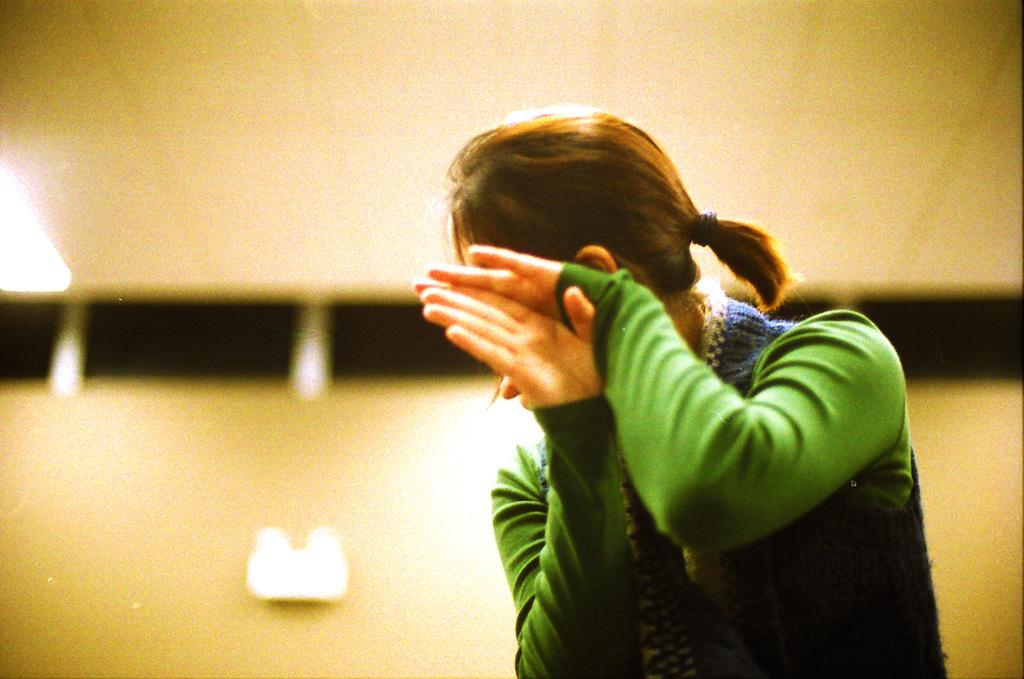Who is the main subject in the image? There is a girl in the image. What is the girl wearing? The girl is wearing a green top. What can be seen in the background of the image? There is a wall and black objects in the background of the image. Can you describe the lighting in the image? There is a light visible in the image. What type of joke is the girl telling in the image? There is no indication in the image that the girl is telling a joke, so it cannot be determined from the picture. 